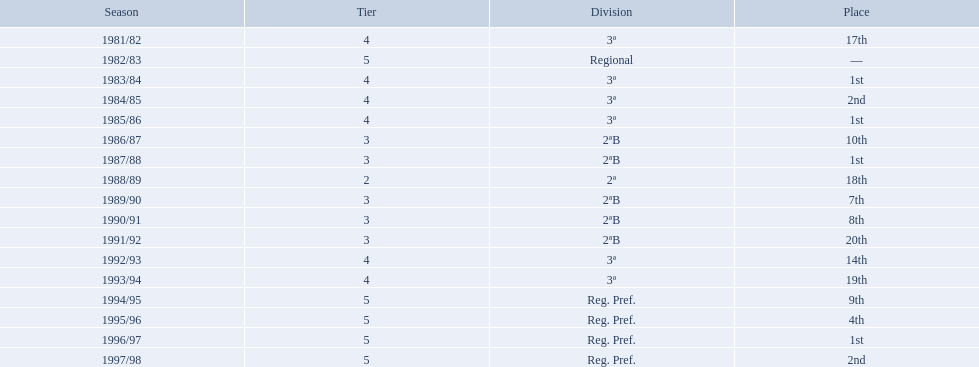Which years did the team have a season? 1981/82, 1982/83, 1983/84, 1984/85, 1985/86, 1986/87, 1987/88, 1988/89, 1989/90, 1990/91, 1991/92, 1992/93, 1993/94, 1994/95, 1995/96, 1996/97, 1997/98. Which of those years did the team place outside the top 10? 1981/82, 1988/89, 1991/92, 1992/93, 1993/94. Which of the years in which the team placed outside the top 10 did they have their worst performance? 1991/92. During which years did the team's performance result in a 17th or worse ranking? 1981/82, 1988/89, 1991/92, 1993/94. In which of those years was their ranking the lowest? 1991/92. In which years was the team active in a season? 1981/82, 1982/83, 1983/84, 1984/85, 1985/86, 1986/87, 1987/88, 1988/89, 1989/90, 1990/91, 1991/92, 1992/93, 1993/94, 1994/95, 1995/96, 1996/97, 1997/98. When did they fail to secure a position in the top 10 during those years? 1981/82, 1988/89, 1991/92, 1992/93, 1993/94. In the years they ranked outside the top 10, when did they have their least successful performance? 1991/92. 